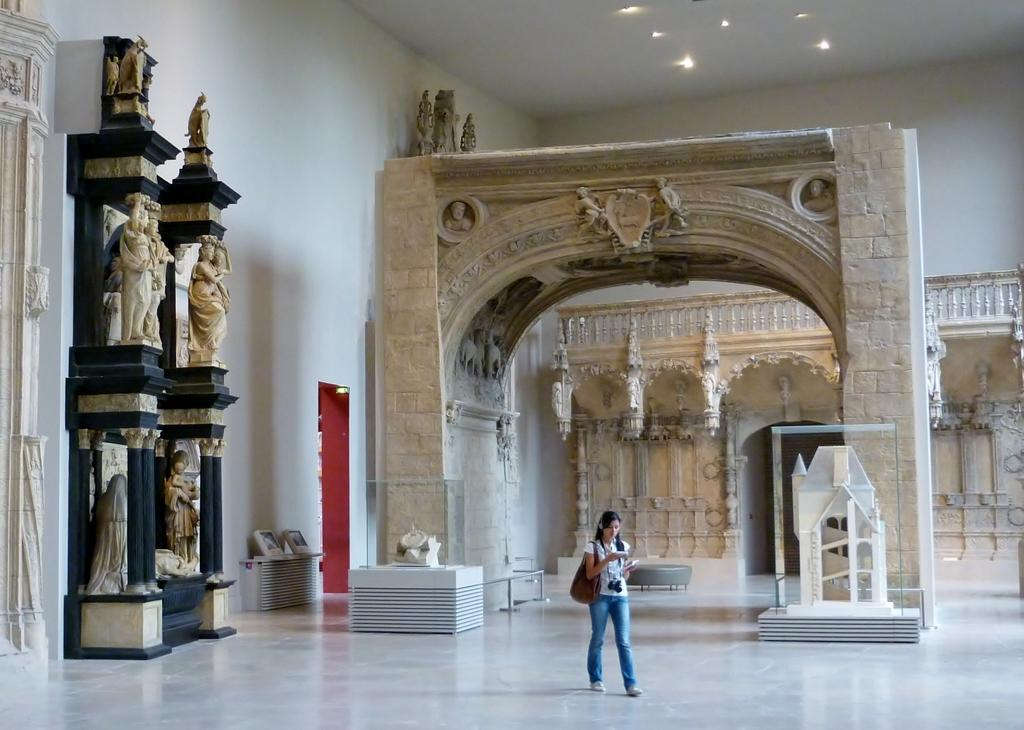What type of structure can be seen in the image? There is an arch in the image. Are there any other architectural features present? Yes, there are statues and a wall in the image. What can be seen illuminating the area? There are lights in the image. What is on the ground in the image? There are objects on the floor in the image. Can you describe the surrounding environment? There are sets of buildings in the image. What is the person in the image doing? There is a person holding something and walking in the image. What type of canvas is the person painting in the image? There is no canvas present in the image, and the person is not depicted as painting. What card game is being played by the statues in the image? The statues are not depicted as playing any card game in the image. 